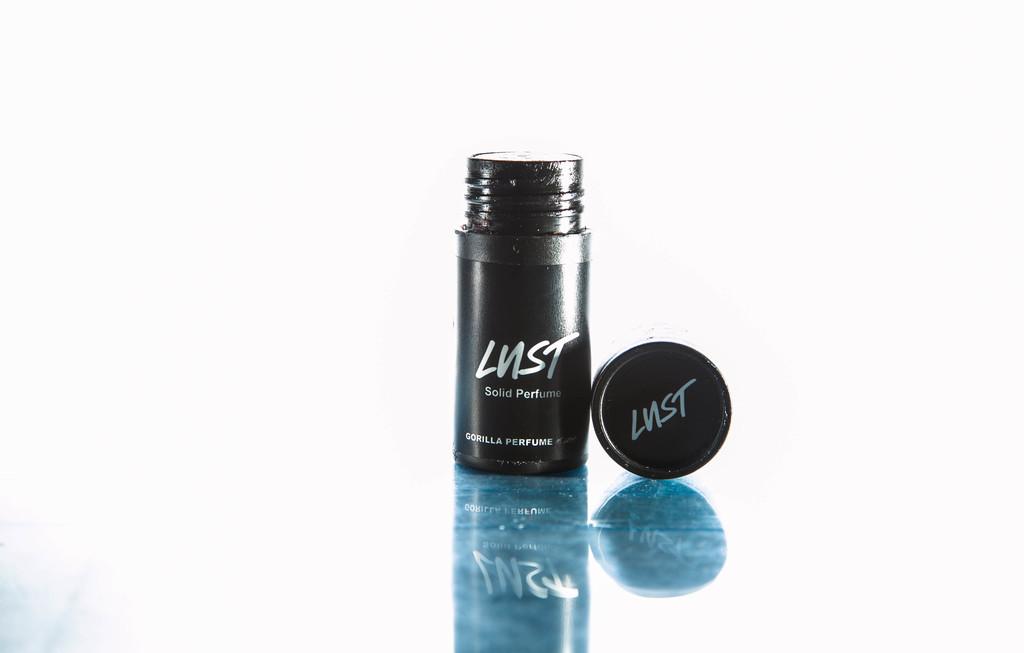What is the name of this perfume?
Provide a short and direct response. Lust. What kind of perfume is this?
Offer a terse response. Lust. 